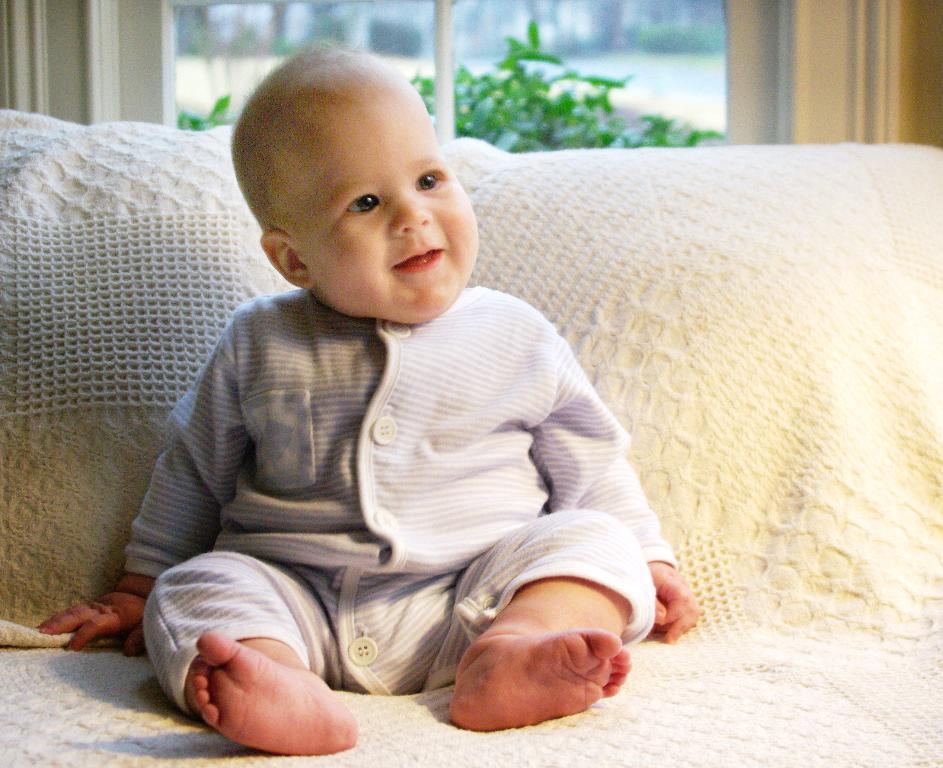Describe this image in one or two sentences. In this picture, we see a baby in the white shirt is sitting on the sofa and he is smiling. Behind that, there is a window from which we can see trees. This picture is clicked inside the room. 